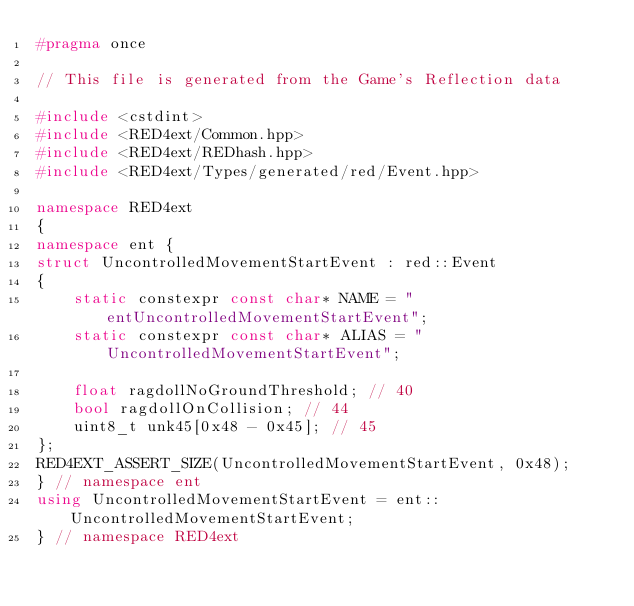Convert code to text. <code><loc_0><loc_0><loc_500><loc_500><_C++_>#pragma once

// This file is generated from the Game's Reflection data

#include <cstdint>
#include <RED4ext/Common.hpp>
#include <RED4ext/REDhash.hpp>
#include <RED4ext/Types/generated/red/Event.hpp>

namespace RED4ext
{
namespace ent { 
struct UncontrolledMovementStartEvent : red::Event
{
    static constexpr const char* NAME = "entUncontrolledMovementStartEvent";
    static constexpr const char* ALIAS = "UncontrolledMovementStartEvent";

    float ragdollNoGroundThreshold; // 40
    bool ragdollOnCollision; // 44
    uint8_t unk45[0x48 - 0x45]; // 45
};
RED4EXT_ASSERT_SIZE(UncontrolledMovementStartEvent, 0x48);
} // namespace ent
using UncontrolledMovementStartEvent = ent::UncontrolledMovementStartEvent;
} // namespace RED4ext
</code> 